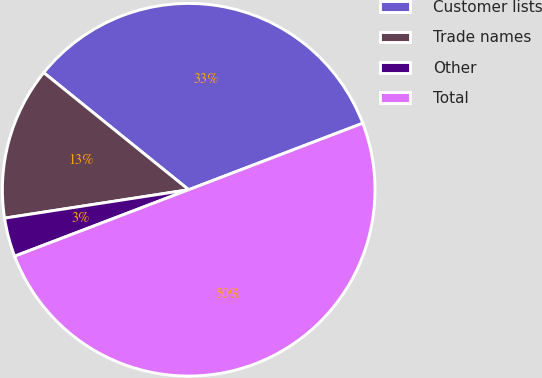Convert chart. <chart><loc_0><loc_0><loc_500><loc_500><pie_chart><fcel>Customer lists<fcel>Trade names<fcel>Other<fcel>Total<nl><fcel>33.38%<fcel>13.25%<fcel>3.37%<fcel>50.0%<nl></chart> 